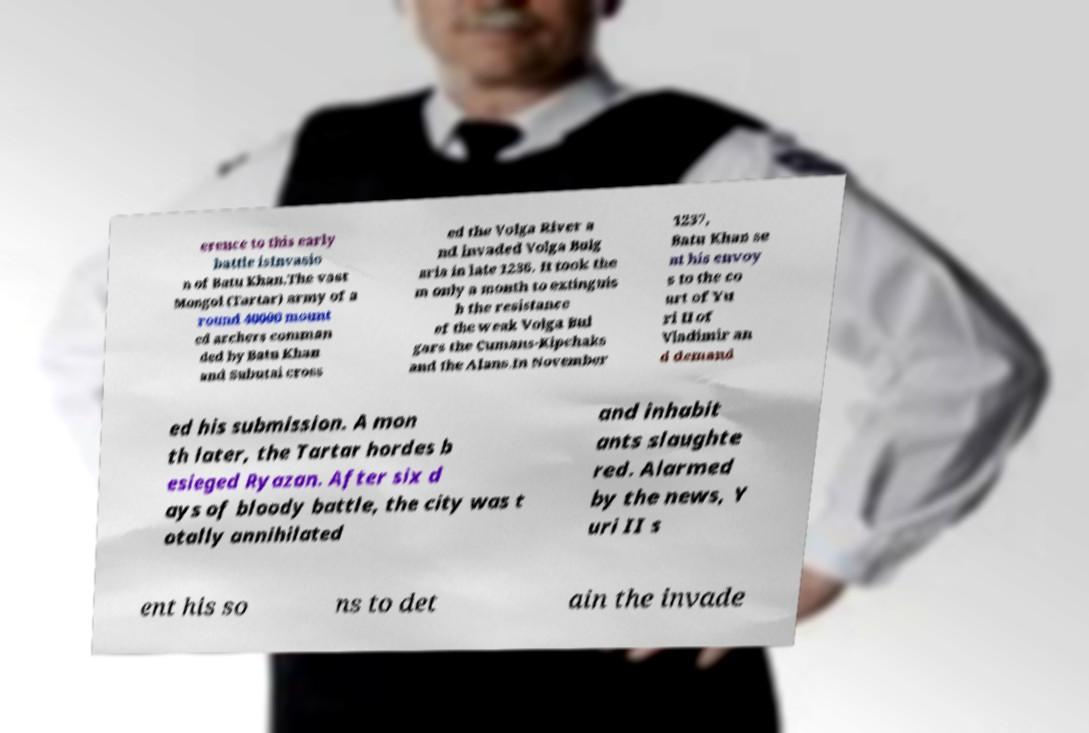For documentation purposes, I need the text within this image transcribed. Could you provide that? erence to this early battle isInvasio n of Batu Khan.The vast Mongol (Tartar) army of a round 40000 mount ed archers comman ded by Batu Khan and Subutai cross ed the Volga River a nd invaded Volga Bulg aria in late 1236. It took the m only a month to extinguis h the resistance of the weak Volga Bul gars the Cumans-Kipchaks and the Alans.In November 1237, Batu Khan se nt his envoy s to the co urt of Yu ri II of Vladimir an d demand ed his submission. A mon th later, the Tartar hordes b esieged Ryazan. After six d ays of bloody battle, the city was t otally annihilated and inhabit ants slaughte red. Alarmed by the news, Y uri II s ent his so ns to det ain the invade 